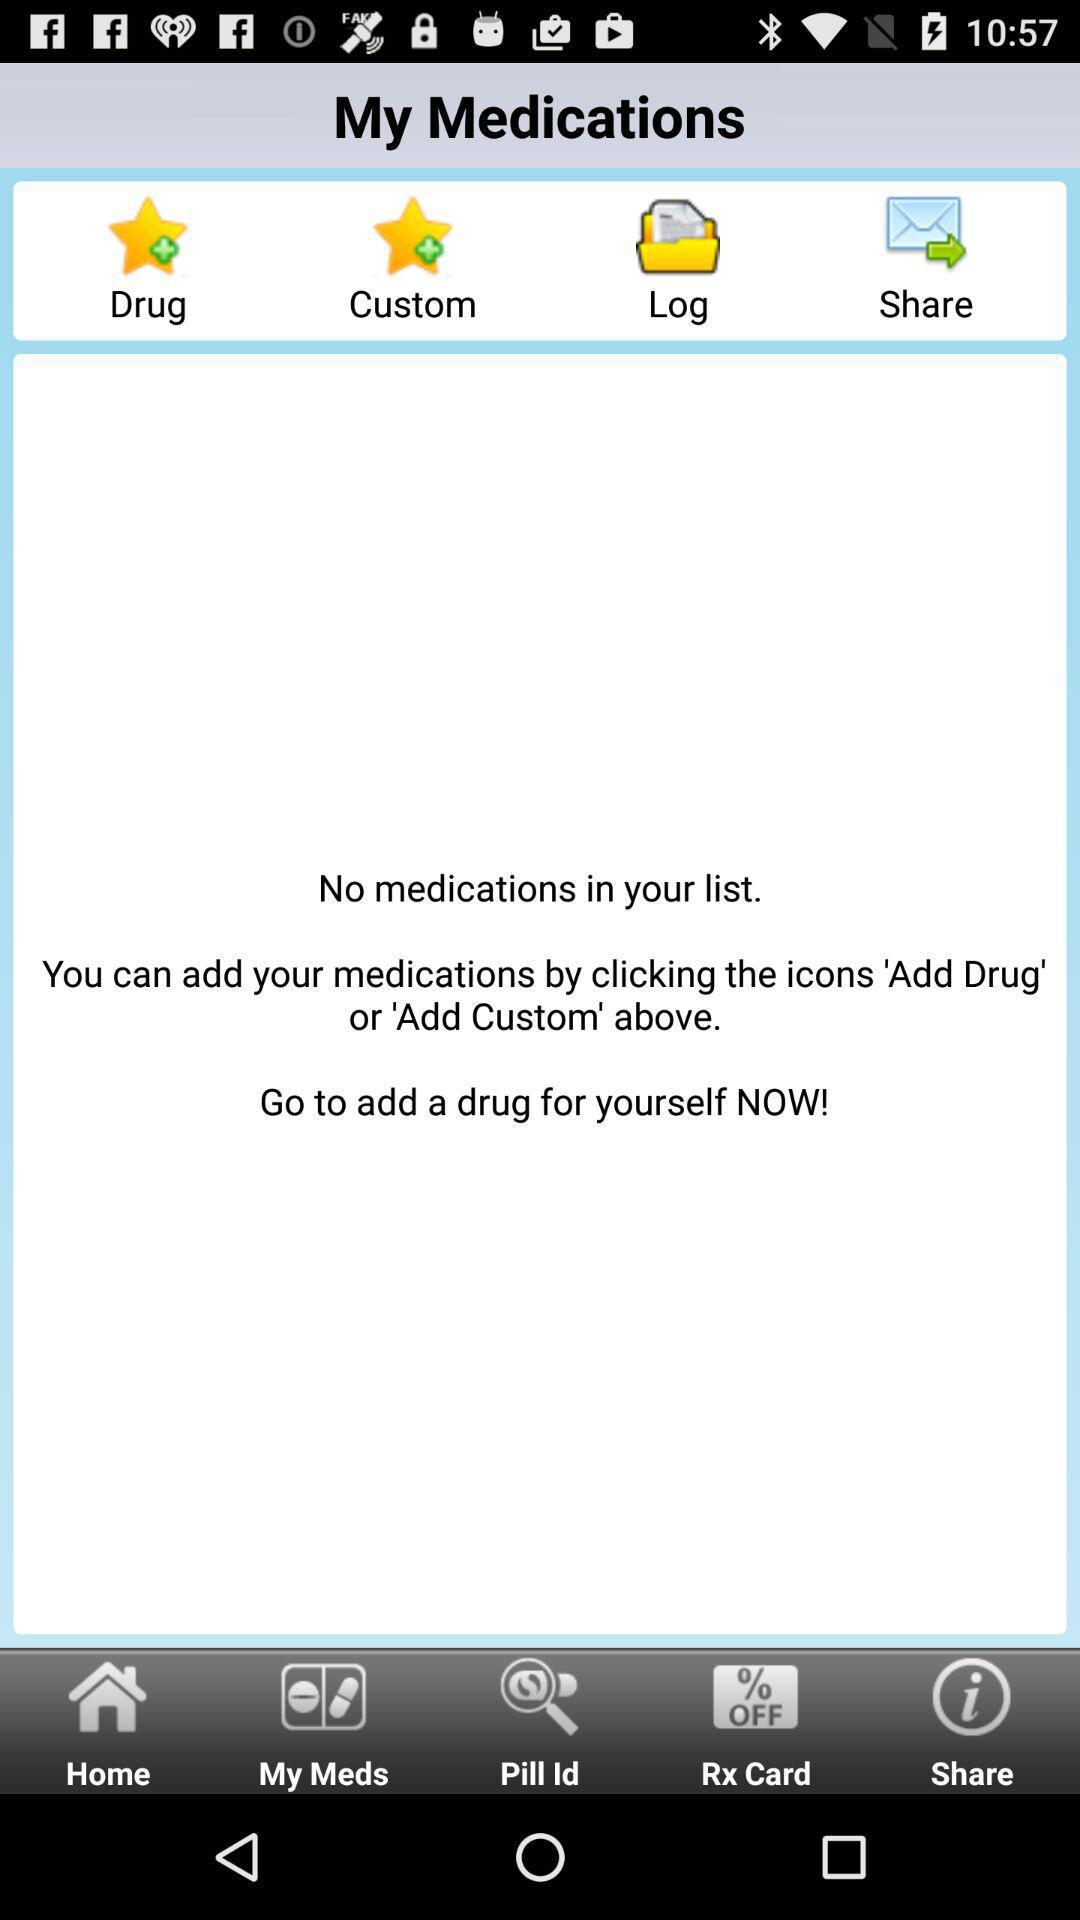How can I add medications? You can add medications by clicking the icons 'Add Drug' or 'Add Custom' above. 